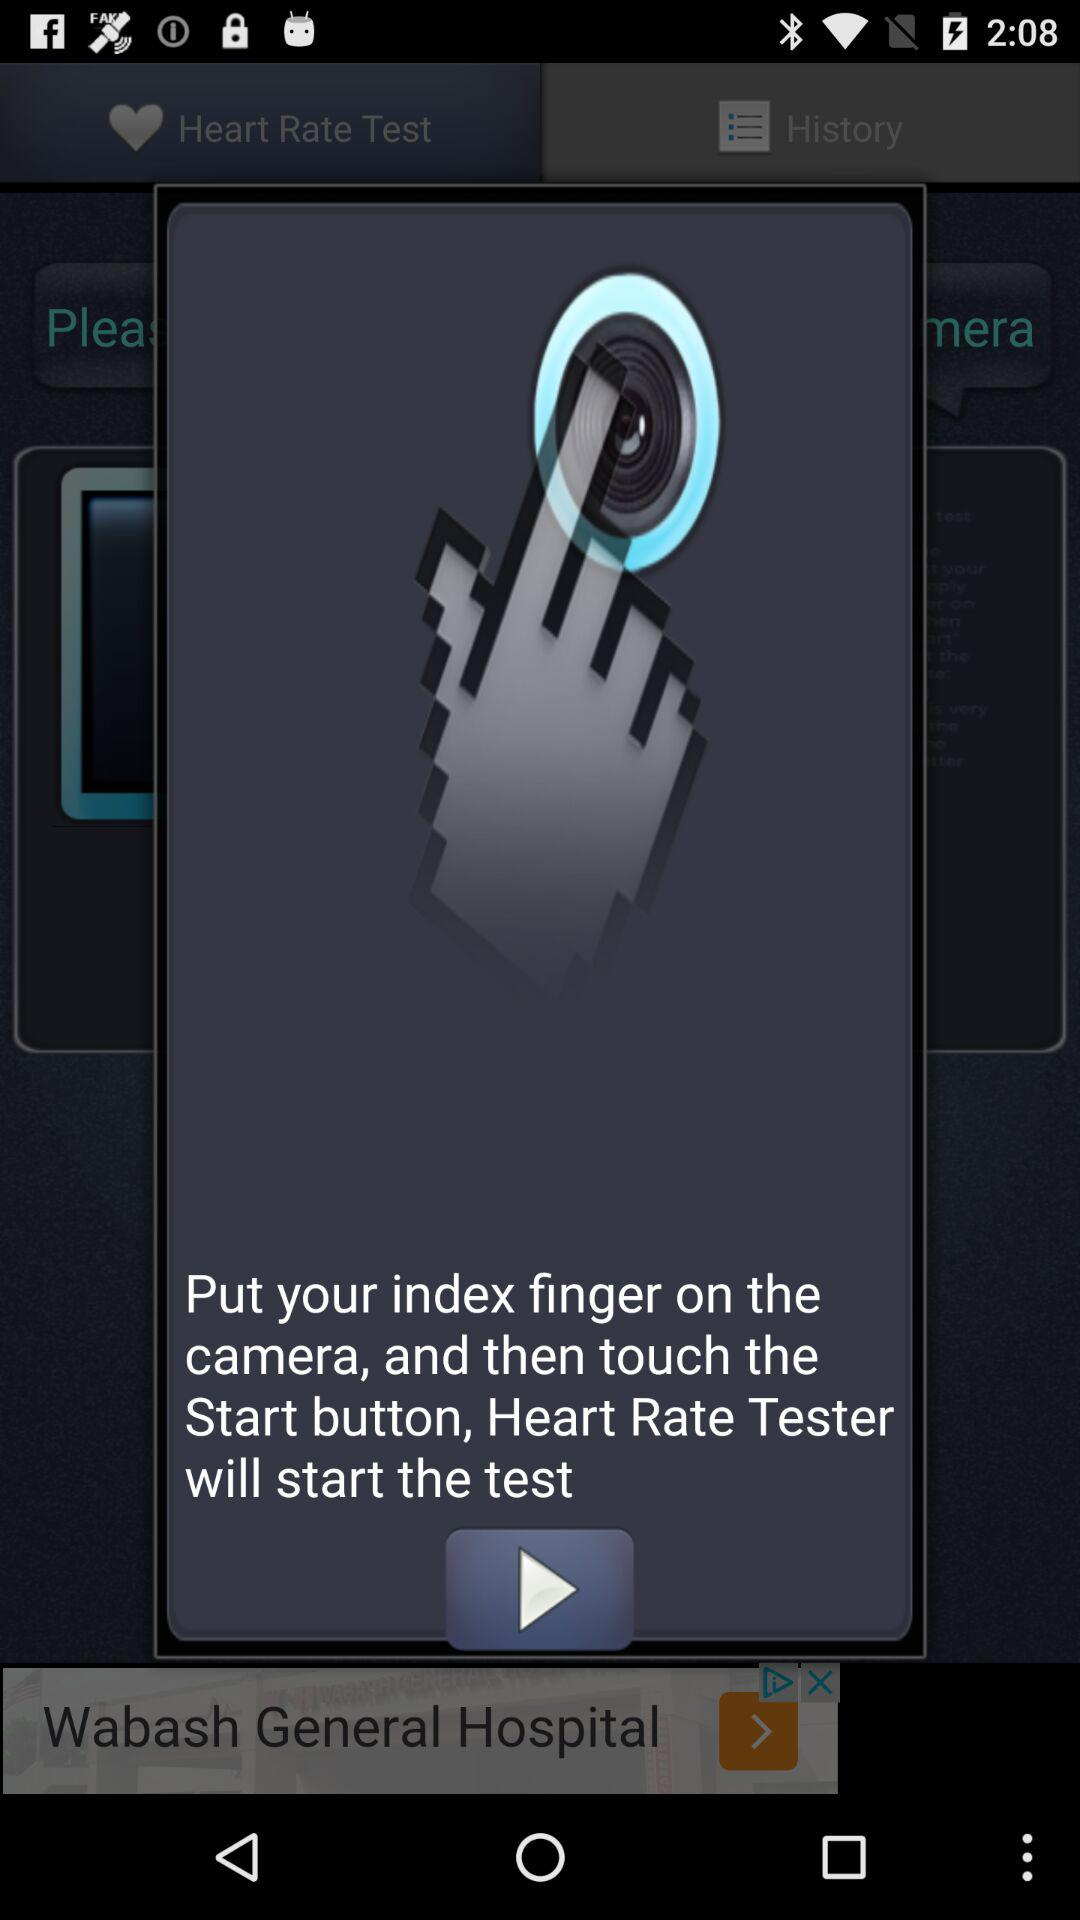Which finger is to be put on the camera? You need to put the index finger on the camera. 